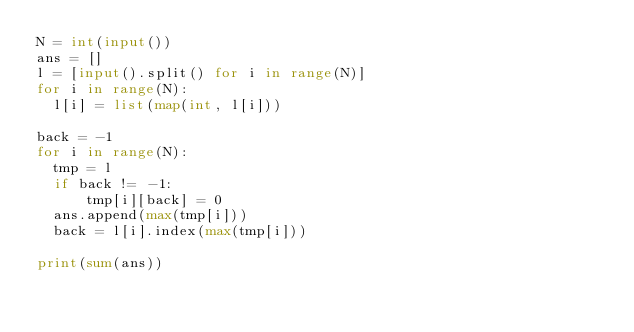Convert code to text. <code><loc_0><loc_0><loc_500><loc_500><_Python_>N = int(input())
ans = []
l = [input().split() for i in range(N)]
for i in range(N):
  l[i] = list(map(int, l[i]))

back = -1
for i in range(N):
  tmp = l
  if back != -1:
      tmp[i][back] = 0
  ans.append(max(tmp[i]))
  back = l[i].index(max(tmp[i]))

print(sum(ans))
</code> 